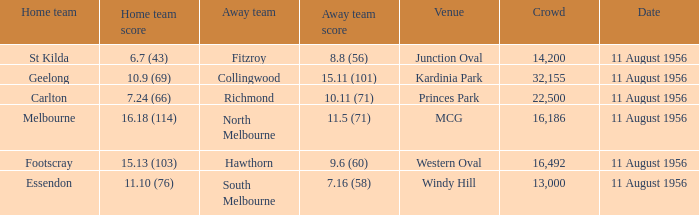Where did a home team score 10.9 (69)? Kardinia Park. 